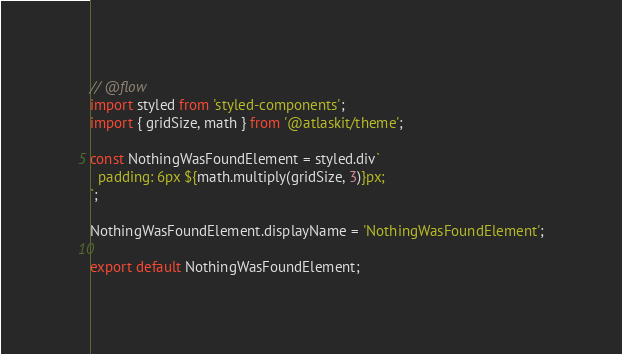<code> <loc_0><loc_0><loc_500><loc_500><_JavaScript_>// @flow
import styled from 'styled-components';
import { gridSize, math } from '@atlaskit/theme';

const NothingWasFoundElement = styled.div`
  padding: 6px ${math.multiply(gridSize, 3)}px;
`;

NothingWasFoundElement.displayName = 'NothingWasFoundElement';

export default NothingWasFoundElement;
</code> 